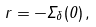<formula> <loc_0><loc_0><loc_500><loc_500>r = - \Sigma _ { \delta } ( 0 ) \, ,</formula> 